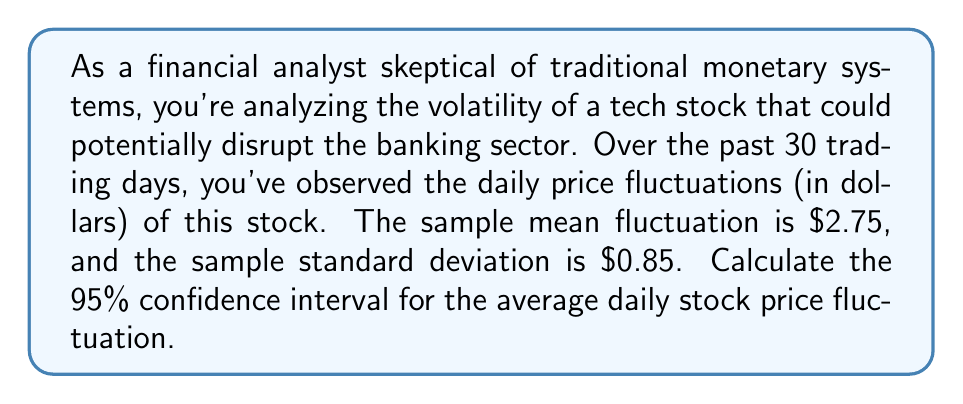Show me your answer to this math problem. Let's approach this step-by-step:

1) We're dealing with a sample size of n = 30 trading days.

2) The sample mean ($\bar{x}$) is $2.75.

3) The sample standard deviation (s) is $0.85.

4) We want a 95% confidence interval, so our confidence level is 0.95.

5) The formula for the confidence interval is:

   $$\bar{x} \pm t_{\alpha/2, n-1} \cdot \frac{s}{\sqrt{n}}$$

   Where $t_{\alpha/2, n-1}$ is the t-value from the t-distribution with n-1 degrees of freedom.

6) For a 95% confidence interval, $\alpha = 1 - 0.95 = 0.05$, and $\alpha/2 = 0.025$.

7) With 29 degrees of freedom (n-1 = 30-1 = 29), the t-value for a two-tailed test at 0.025 is approximately 2.045.

8) Now, let's plug everything into our formula:

   $$2.75 \pm 2.045 \cdot \frac{0.85}{\sqrt{30}}$$

9) Simplify:
   $$2.75 \pm 2.045 \cdot 0.1552 = 2.75 \pm 0.3174$$

10) Therefore, our confidence interval is:
    $$(2.75 - 0.3174, 2.75 + 0.3174) = (2.4326, 3.0674)$$

We can be 95% confident that the true average daily stock price fluctuation falls between $2.43 and $3.07.
Answer: ($2.43, $3.07) 